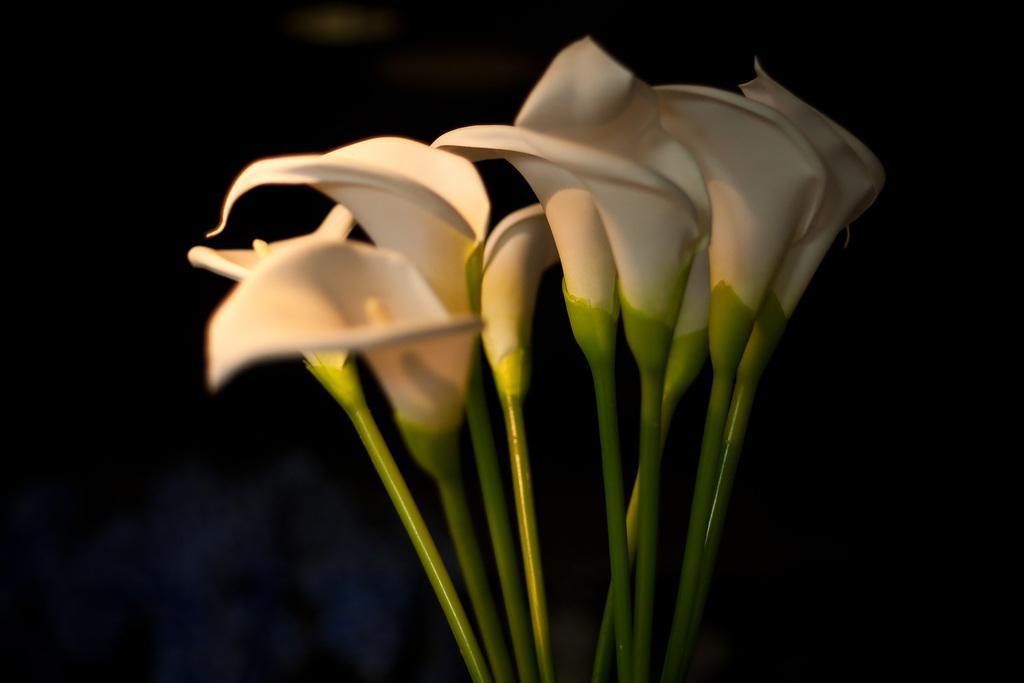Can you describe this image briefly? In this image in the front there are flowers. 